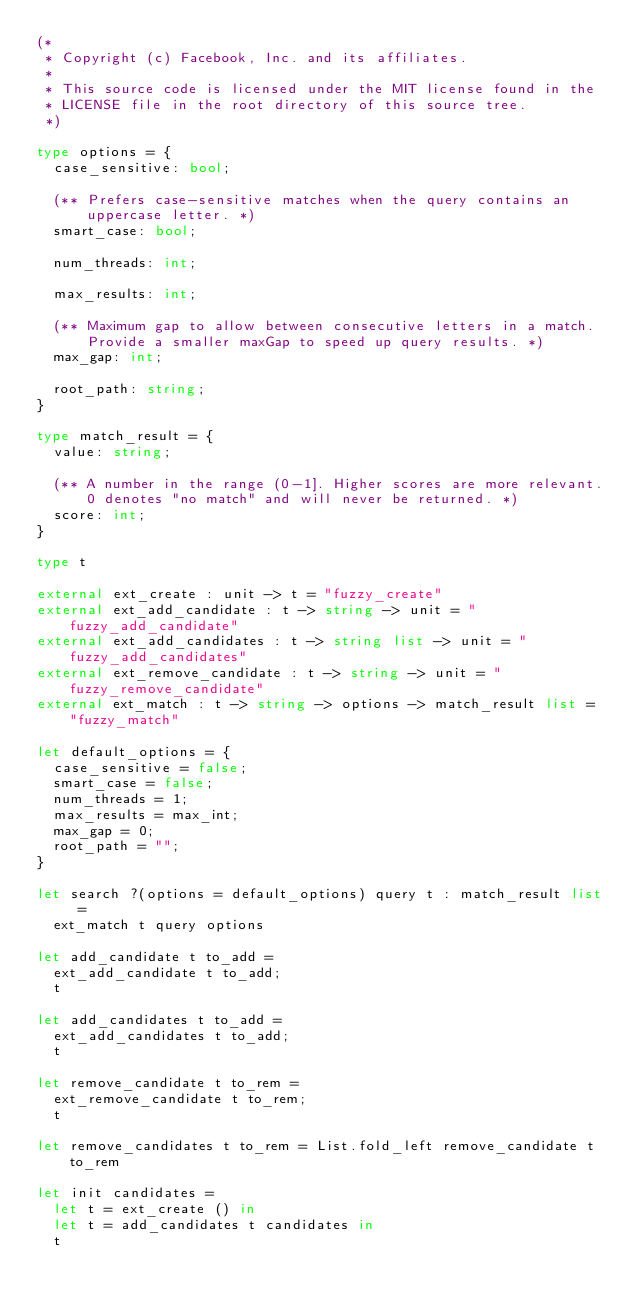Convert code to text. <code><loc_0><loc_0><loc_500><loc_500><_OCaml_>(*
 * Copyright (c) Facebook, Inc. and its affiliates.
 *
 * This source code is licensed under the MIT license found in the
 * LICENSE file in the root directory of this source tree.
 *)

type options = {
  case_sensitive: bool;

  (** Prefers case-sensitive matches when the query contains an uppercase letter. *)
  smart_case: bool;

  num_threads: int;

  max_results: int;

  (** Maximum gap to allow between consecutive letters in a match.
      Provide a smaller maxGap to speed up query results. *)
  max_gap: int;

  root_path: string;
}

type match_result = {
  value: string;

  (** A number in the range (0-1]. Higher scores are more relevant.
      0 denotes "no match" and will never be returned. *)
  score: int;
}

type t

external ext_create : unit -> t = "fuzzy_create"
external ext_add_candidate : t -> string -> unit = "fuzzy_add_candidate"
external ext_add_candidates : t -> string list -> unit = "fuzzy_add_candidates"
external ext_remove_candidate : t -> string -> unit = "fuzzy_remove_candidate"
external ext_match : t -> string -> options -> match_result list = "fuzzy_match"

let default_options = {
  case_sensitive = false;
  smart_case = false;
  num_threads = 1;
  max_results = max_int;
  max_gap = 0;
  root_path = "";
}

let search ?(options = default_options) query t : match_result list =
  ext_match t query options

let add_candidate t to_add =
  ext_add_candidate t to_add;
  t

let add_candidates t to_add =
  ext_add_candidates t to_add;
  t

let remove_candidate t to_rem =
  ext_remove_candidate t to_rem;
  t

let remove_candidates t to_rem = List.fold_left remove_candidate t to_rem

let init candidates =
  let t = ext_create () in
  let t = add_candidates t candidates in
  t
</code> 